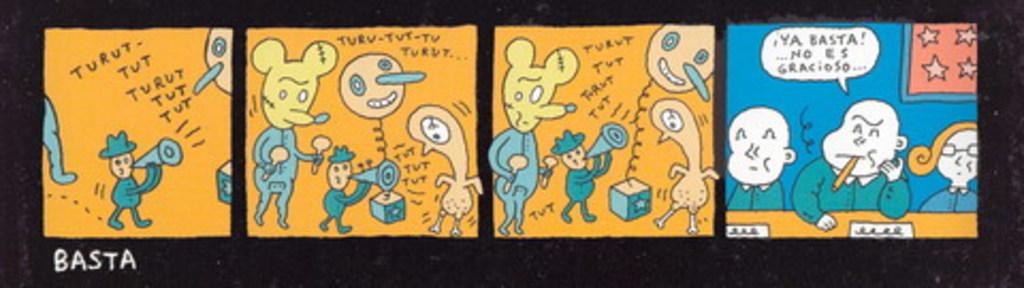What is the title for this comic stip?
Your response must be concise. Basta. Is the comic in english?
Provide a succinct answer. No. 